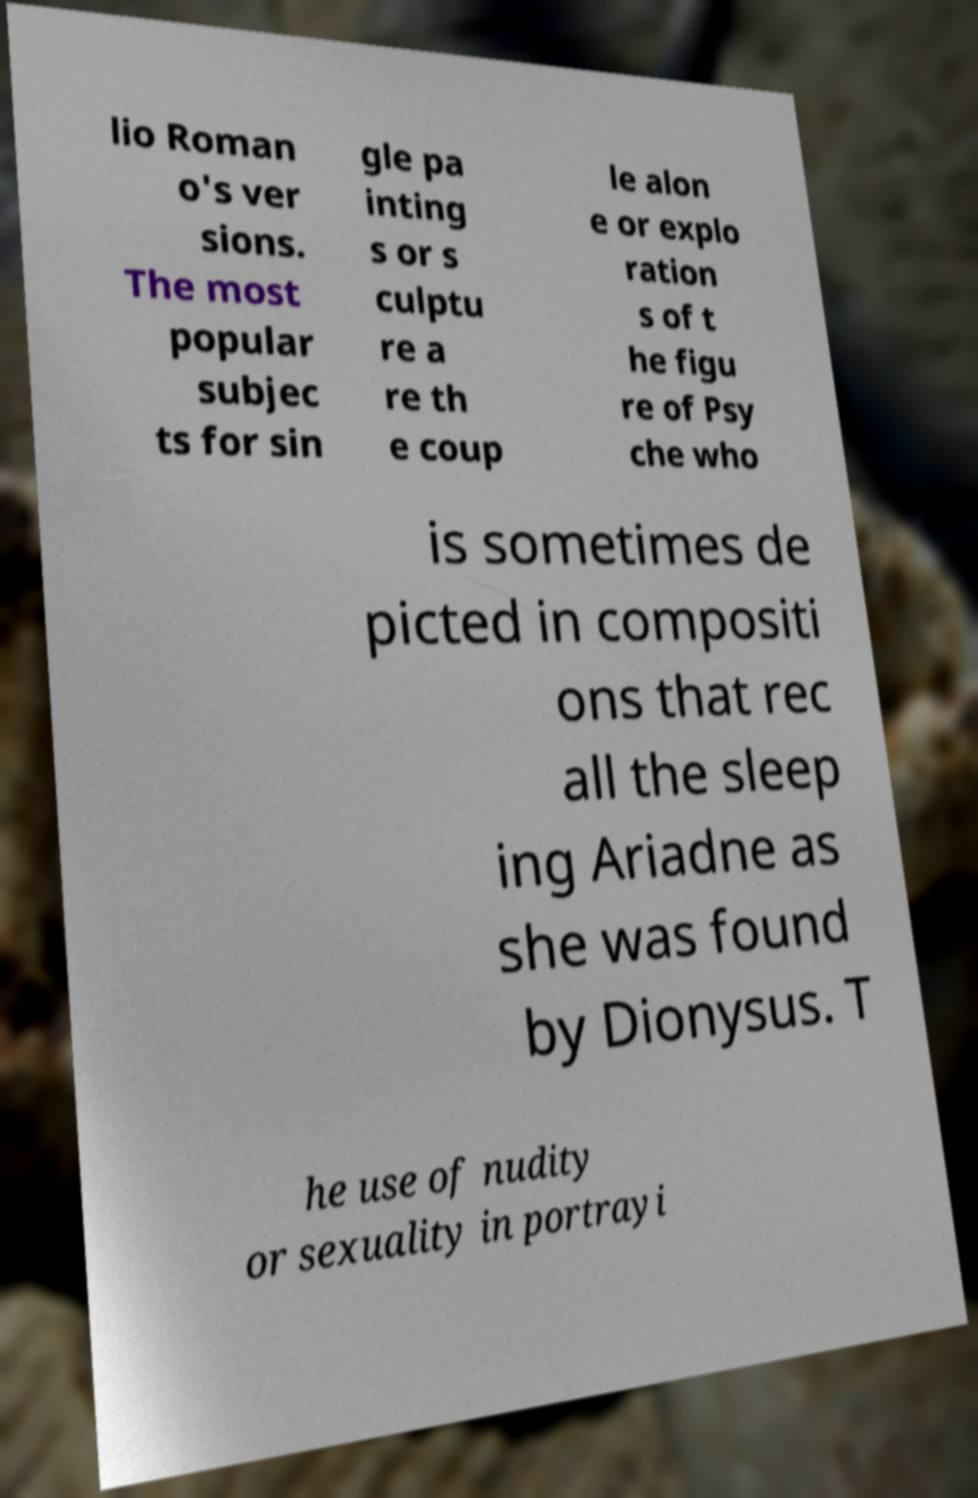Please identify and transcribe the text found in this image. lio Roman o's ver sions. The most popular subjec ts for sin gle pa inting s or s culptu re a re th e coup le alon e or explo ration s of t he figu re of Psy che who is sometimes de picted in compositi ons that rec all the sleep ing Ariadne as she was found by Dionysus. T he use of nudity or sexuality in portrayi 